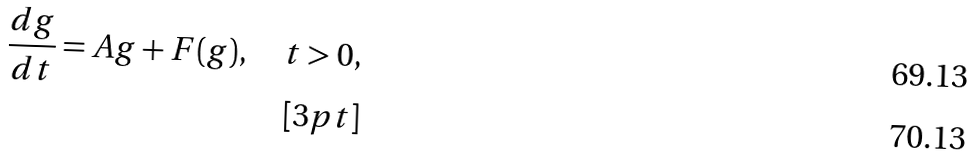<formula> <loc_0><loc_0><loc_500><loc_500>\frac { d g } { d t } = A g + F ( g ) , \quad t > 0 , \\ [ 3 p t ]</formula> 